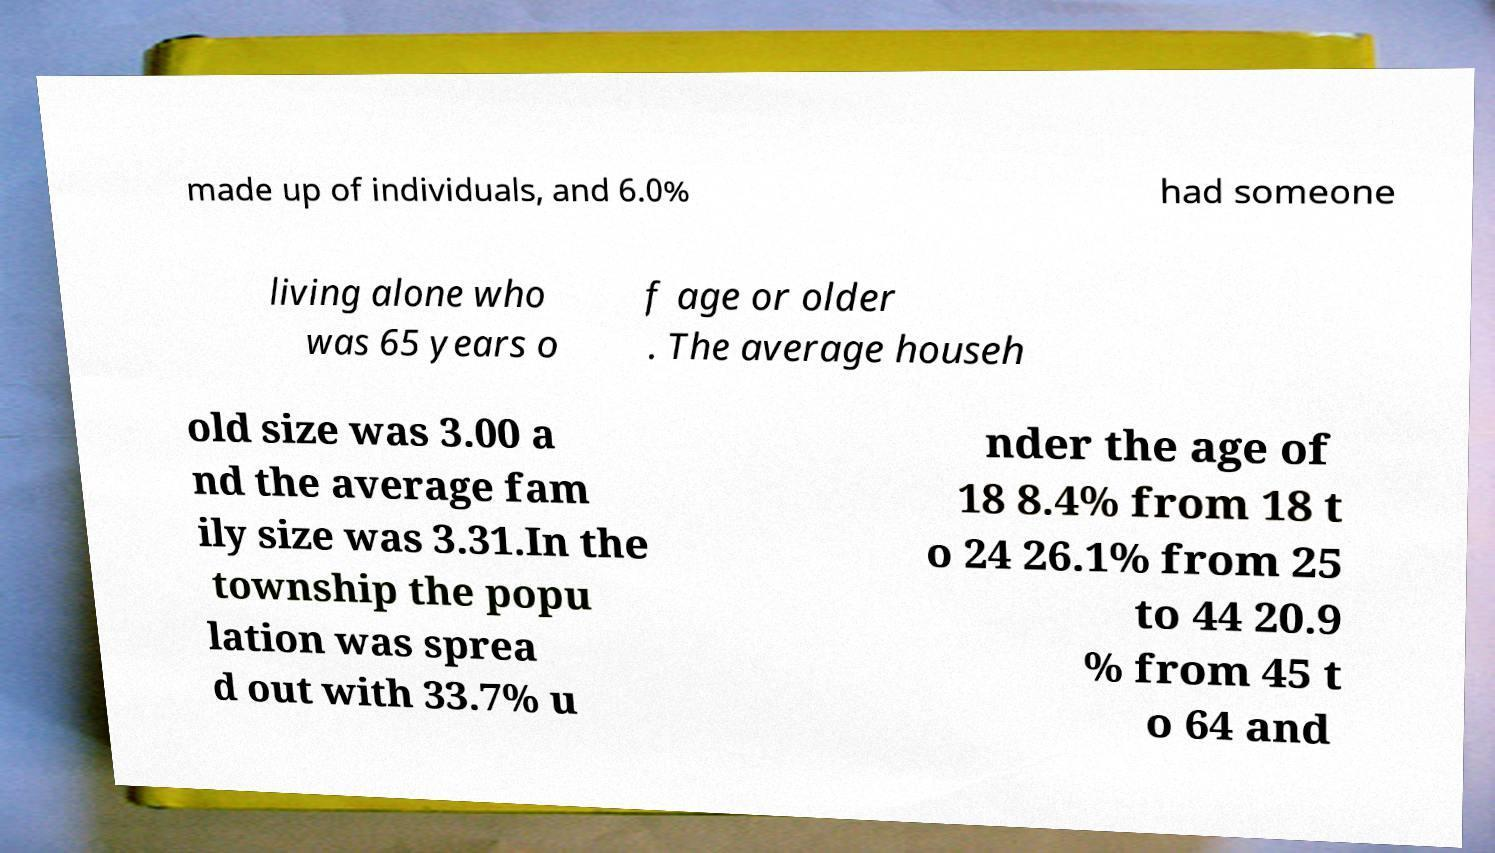For documentation purposes, I need the text within this image transcribed. Could you provide that? made up of individuals, and 6.0% had someone living alone who was 65 years o f age or older . The average househ old size was 3.00 a nd the average fam ily size was 3.31.In the township the popu lation was sprea d out with 33.7% u nder the age of 18 8.4% from 18 t o 24 26.1% from 25 to 44 20.9 % from 45 t o 64 and 